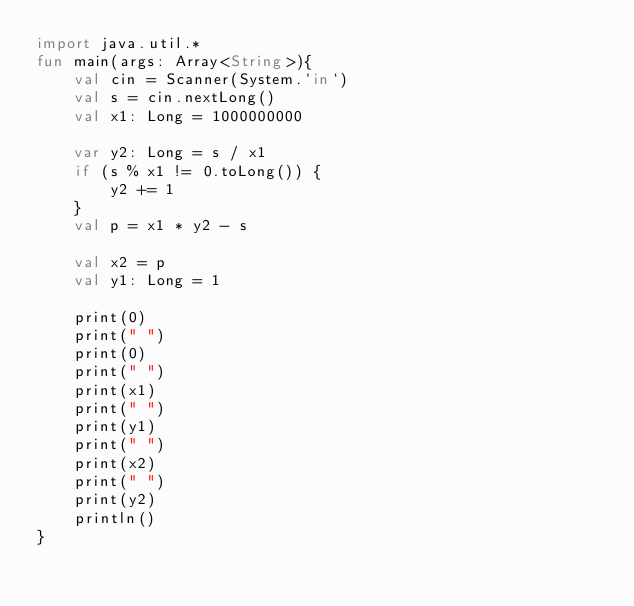<code> <loc_0><loc_0><loc_500><loc_500><_Kotlin_>import java.util.*
fun main(args: Array<String>){
	val cin = Scanner(System.`in`)
    val s = cin.nextLong()
    val x1: Long = 1000000000

    var y2: Long = s / x1
    if (s % x1 != 0.toLong()) {
        y2 += 1
    }
    val p = x1 * y2 - s

    val x2 = p
    val y1: Long = 1

    print(0)
    print(" ")
    print(0)
    print(" ")
    print(x1)
    print(" ")
    print(y1)
    print(" ")
    print(x2)
    print(" ")
    print(y2)
    println()
}</code> 